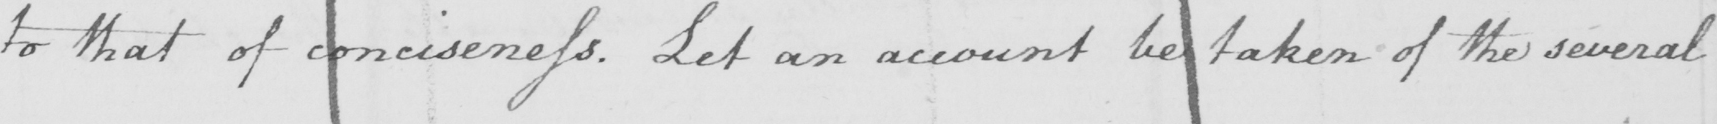Please transcribe the handwritten text in this image. to that of conciseness . Let an account be taken of the several 